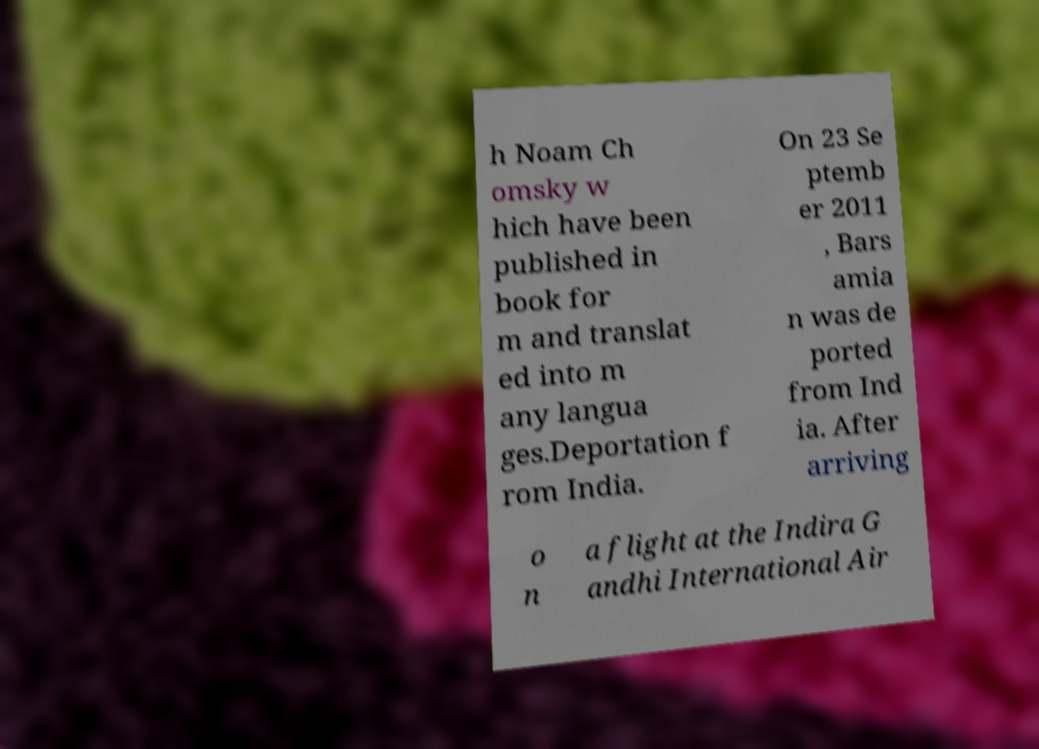Could you assist in decoding the text presented in this image and type it out clearly? h Noam Ch omsky w hich have been published in book for m and translat ed into m any langua ges.Deportation f rom India. On 23 Se ptemb er 2011 , Bars amia n was de ported from Ind ia. After arriving o n a flight at the Indira G andhi International Air 